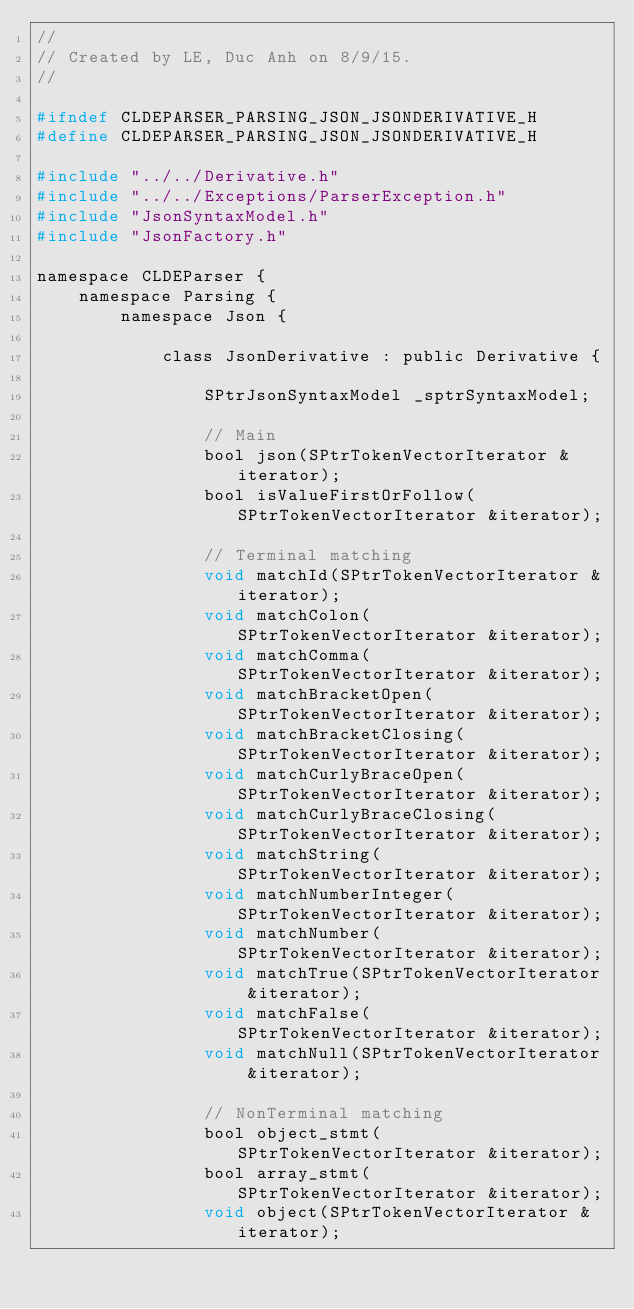Convert code to text. <code><loc_0><loc_0><loc_500><loc_500><_C_>//
// Created by LE, Duc Anh on 8/9/15.
//

#ifndef CLDEPARSER_PARSING_JSON_JSONDERIVATIVE_H
#define CLDEPARSER_PARSING_JSON_JSONDERIVATIVE_H

#include "../../Derivative.h"
#include "../../Exceptions/ParserException.h"
#include "JsonSyntaxModel.h"
#include "JsonFactory.h"

namespace CLDEParser {
    namespace Parsing {
        namespace Json {

            class JsonDerivative : public Derivative {

                SPtrJsonSyntaxModel _sptrSyntaxModel;

                // Main
                bool json(SPtrTokenVectorIterator &iterator);
                bool isValueFirstOrFollow(SPtrTokenVectorIterator &iterator);

                // Terminal matching
                void matchId(SPtrTokenVectorIterator &iterator);
                void matchColon(SPtrTokenVectorIterator &iterator);
                void matchComma(SPtrTokenVectorIterator &iterator);
                void matchBracketOpen(SPtrTokenVectorIterator &iterator);
                void matchBracketClosing(SPtrTokenVectorIterator &iterator);
                void matchCurlyBraceOpen(SPtrTokenVectorIterator &iterator);
                void matchCurlyBraceClosing(SPtrTokenVectorIterator &iterator);
                void matchString(SPtrTokenVectorIterator &iterator);
                void matchNumberInteger(SPtrTokenVectorIterator &iterator);
                void matchNumber(SPtrTokenVectorIterator &iterator);
                void matchTrue(SPtrTokenVectorIterator &iterator);
                void matchFalse(SPtrTokenVectorIterator &iterator);
                void matchNull(SPtrTokenVectorIterator &iterator);

                // NonTerminal matching
                bool object_stmt(SPtrTokenVectorIterator &iterator);
                bool array_stmt(SPtrTokenVectorIterator &iterator);
                void object(SPtrTokenVectorIterator &iterator);</code> 